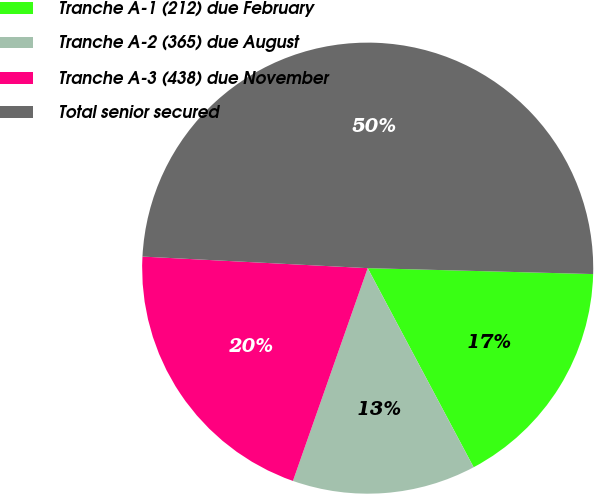Convert chart. <chart><loc_0><loc_0><loc_500><loc_500><pie_chart><fcel>Tranche A-1 (212) due February<fcel>Tranche A-2 (365) due August<fcel>Tranche A-3 (438) due November<fcel>Total senior secured<nl><fcel>16.8%<fcel>13.16%<fcel>20.44%<fcel>49.6%<nl></chart> 